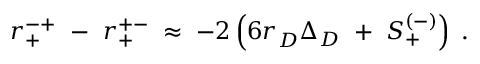<formula> <loc_0><loc_0><loc_500><loc_500>r _ { + } ^ { - + } - r _ { + } ^ { + - } \, \approx \, - 2 \left ( 6 r _ { D } \Delta _ { D } + S _ { + } ^ { ( - ) } \right ) \, .</formula> 